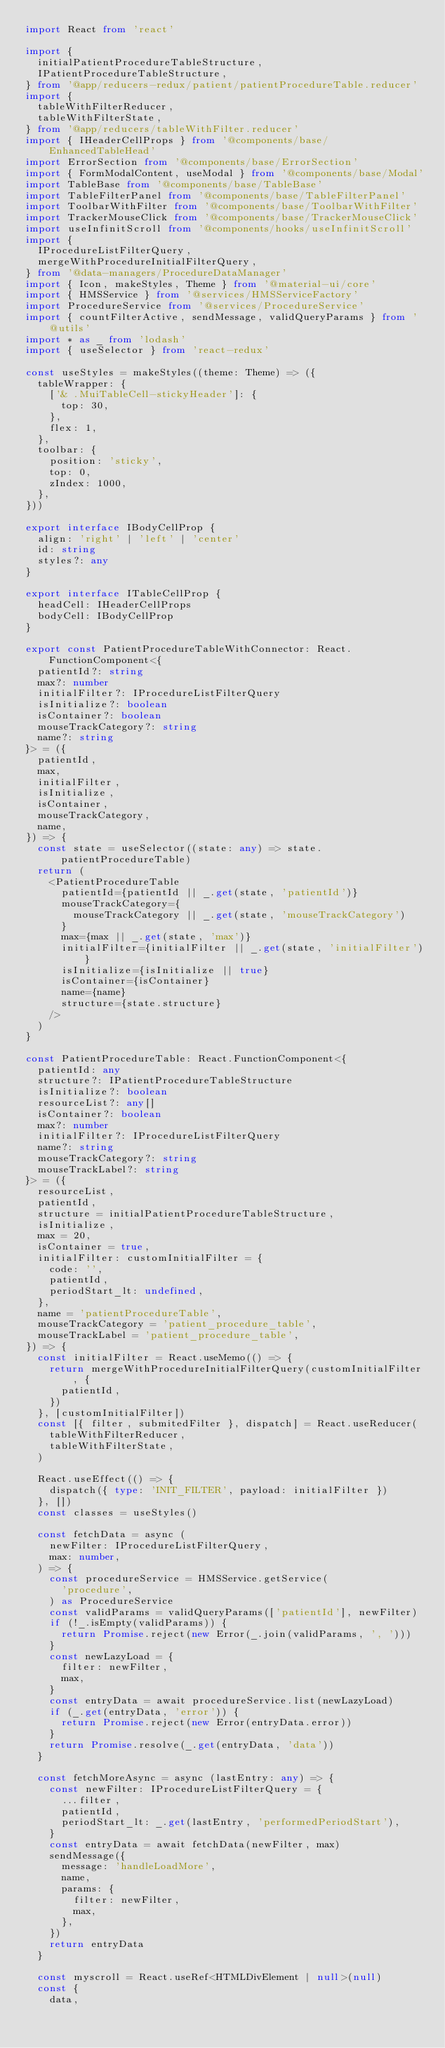<code> <loc_0><loc_0><loc_500><loc_500><_TypeScript_>import React from 'react'

import {
  initialPatientProcedureTableStructure,
  IPatientProcedureTableStructure,
} from '@app/reducers-redux/patient/patientProcedureTable.reducer'
import {
  tableWithFilterReducer,
  tableWithFilterState,
} from '@app/reducers/tableWithFilter.reducer'
import { IHeaderCellProps } from '@components/base/EnhancedTableHead'
import ErrorSection from '@components/base/ErrorSection'
import { FormModalContent, useModal } from '@components/base/Modal'
import TableBase from '@components/base/TableBase'
import TableFilterPanel from '@components/base/TableFilterPanel'
import ToolbarWithFilter from '@components/base/ToolbarWithFilter'
import TrackerMouseClick from '@components/base/TrackerMouseClick'
import useInfinitScroll from '@components/hooks/useInfinitScroll'
import {
  IProcedureListFilterQuery,
  mergeWithProcedureInitialFilterQuery,
} from '@data-managers/ProcedureDataManager'
import { Icon, makeStyles, Theme } from '@material-ui/core'
import { HMSService } from '@services/HMSServiceFactory'
import ProcedureService from '@services/ProcedureService'
import { countFilterActive, sendMessage, validQueryParams } from '@utils'
import * as _ from 'lodash'
import { useSelector } from 'react-redux'

const useStyles = makeStyles((theme: Theme) => ({
  tableWrapper: {
    ['& .MuiTableCell-stickyHeader']: {
      top: 30,
    },
    flex: 1,
  },
  toolbar: {
    position: 'sticky',
    top: 0,
    zIndex: 1000,
  },
}))

export interface IBodyCellProp {
  align: 'right' | 'left' | 'center'
  id: string
  styles?: any
}

export interface ITableCellProp {
  headCell: IHeaderCellProps
  bodyCell: IBodyCellProp
}

export const PatientProcedureTableWithConnector: React.FunctionComponent<{
  patientId?: string
  max?: number
  initialFilter?: IProcedureListFilterQuery
  isInitialize?: boolean
  isContainer?: boolean
  mouseTrackCategory?: string
  name?: string
}> = ({
  patientId,
  max,
  initialFilter,
  isInitialize,
  isContainer,
  mouseTrackCategory,
  name,
}) => {
  const state = useSelector((state: any) => state.patientProcedureTable)
  return (
    <PatientProcedureTable
      patientId={patientId || _.get(state, 'patientId')}
      mouseTrackCategory={
        mouseTrackCategory || _.get(state, 'mouseTrackCategory')
      }
      max={max || _.get(state, 'max')}
      initialFilter={initialFilter || _.get(state, 'initialFilter')}
      isInitialize={isInitialize || true}
      isContainer={isContainer}
      name={name}
      structure={state.structure}
    />
  )
}

const PatientProcedureTable: React.FunctionComponent<{
  patientId: any
  structure?: IPatientProcedureTableStructure
  isInitialize?: boolean
  resourceList?: any[]
  isContainer?: boolean
  max?: number
  initialFilter?: IProcedureListFilterQuery
  name?: string
  mouseTrackCategory?: string
  mouseTrackLabel?: string
}> = ({
  resourceList,
  patientId,
  structure = initialPatientProcedureTableStructure,
  isInitialize,
  max = 20,
  isContainer = true,
  initialFilter: customInitialFilter = {
    code: '',
    patientId,
    periodStart_lt: undefined,
  },
  name = 'patientProcedureTable',
  mouseTrackCategory = 'patient_procedure_table',
  mouseTrackLabel = 'patient_procedure_table',
}) => {
  const initialFilter = React.useMemo(() => {
    return mergeWithProcedureInitialFilterQuery(customInitialFilter, {
      patientId,
    })
  }, [customInitialFilter])
  const [{ filter, submitedFilter }, dispatch] = React.useReducer(
    tableWithFilterReducer,
    tableWithFilterState,
  )

  React.useEffect(() => {
    dispatch({ type: 'INIT_FILTER', payload: initialFilter })
  }, [])
  const classes = useStyles()

  const fetchData = async (
    newFilter: IProcedureListFilterQuery,
    max: number,
  ) => {
    const procedureService = HMSService.getService(
      'procedure',
    ) as ProcedureService
    const validParams = validQueryParams(['patientId'], newFilter)
    if (!_.isEmpty(validParams)) {
      return Promise.reject(new Error(_.join(validParams, ', ')))
    }
    const newLazyLoad = {
      filter: newFilter,
      max,
    }
    const entryData = await procedureService.list(newLazyLoad)
    if (_.get(entryData, 'error')) {
      return Promise.reject(new Error(entryData.error))
    }
    return Promise.resolve(_.get(entryData, 'data'))
  }

  const fetchMoreAsync = async (lastEntry: any) => {
    const newFilter: IProcedureListFilterQuery = {
      ...filter,
      patientId,
      periodStart_lt: _.get(lastEntry, 'performedPeriodStart'),
    }
    const entryData = await fetchData(newFilter, max)
    sendMessage({
      message: 'handleLoadMore',
      name,
      params: {
        filter: newFilter,
        max,
      },
    })
    return entryData
  }

  const myscroll = React.useRef<HTMLDivElement | null>(null)
  const {
    data,</code> 